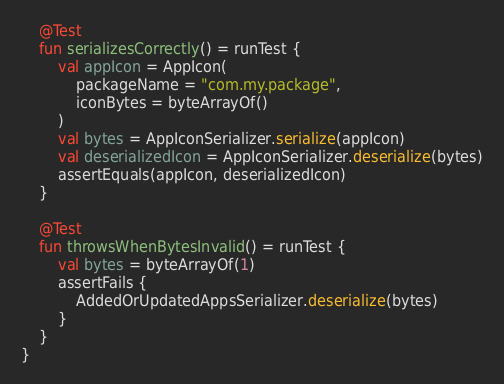<code> <loc_0><loc_0><loc_500><loc_500><_Kotlin_>    @Test
    fun serializesCorrectly() = runTest {
        val appIcon = AppIcon(
            packageName = "com.my.package",
            iconBytes = byteArrayOf()
        )
        val bytes = AppIconSerializer.serialize(appIcon)
        val deserializedIcon = AppIconSerializer.deserialize(bytes)
        assertEquals(appIcon, deserializedIcon)
    }

    @Test
    fun throwsWhenBytesInvalid() = runTest {
        val bytes = byteArrayOf(1)
        assertFails {
            AddedOrUpdatedAppsSerializer.deserialize(bytes)
        }
    }
}
</code> 